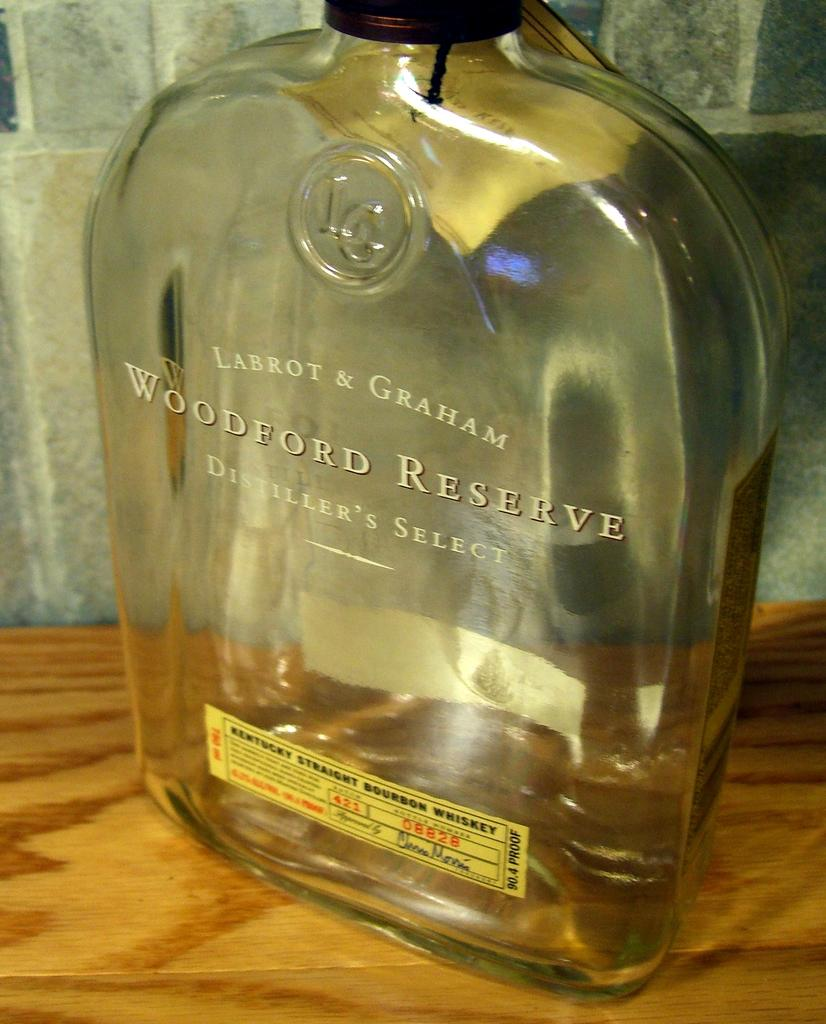Provide a one-sentence caption for the provided image. A bottle of Woodford Reserve wine sitting on wood table. 